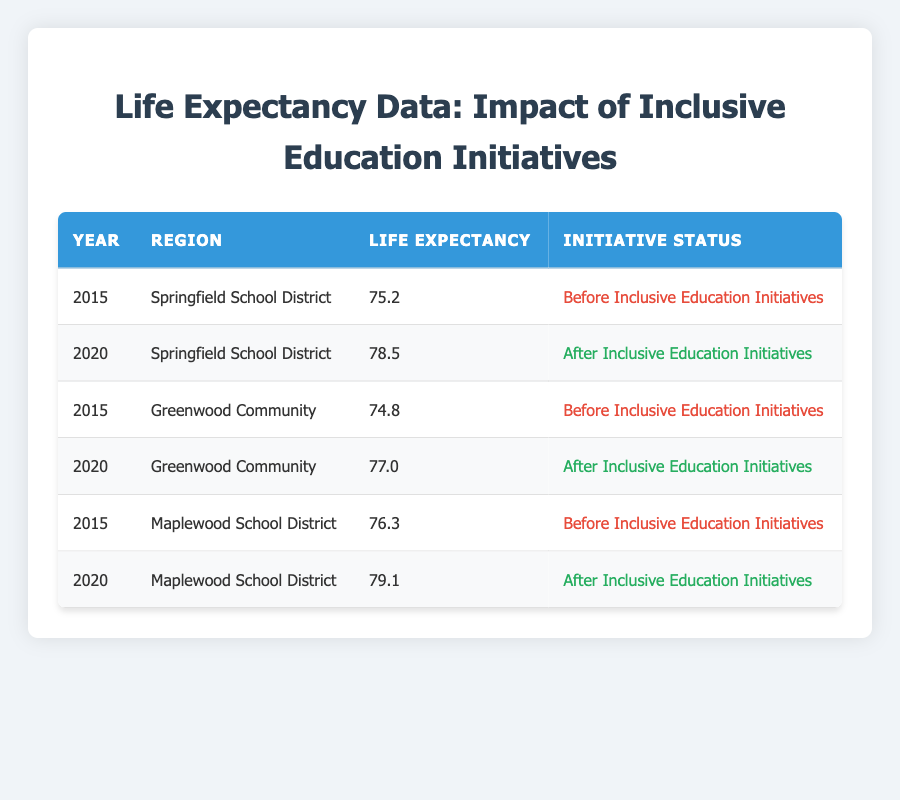What was the life expectancy in Springfield School District before inclusive education initiatives? In the table, we find the row corresponding to the year 2015 for Springfield School District. The life expectancy for that year is listed as 75.2.
Answer: 75.2 What is the life expectancy in Maplewood School District after inclusive education initiatives? Looking at the table, the relevant row for Maplewood School District in the year 2020 shows a life expectancy of 79.1.
Answer: 79.1 Which region had a life expectancy of 74.8 before the inclusive education initiatives? By examining the table, we see that the Greenwood Community shows a life expectancy of 74.8 in the year 2015, which is before the initiatives.
Answer: Greenwood Community What is the increase in life expectancy for Springfield School District from 2015 to 2020? To find this, we take the life expectancy after initiatives (78.5) and subtract the life expectancy before initiatives (75.2): 78.5 - 75.2 = 3.3.
Answer: 3.3 Did life expectancy increase in all regions after the inclusive education initiatives? Analyzing the table, we see that in all regions listed, the life expectancy increased from the years before to after the initiatives: Springfield increased from 75.2 to 78.5, Greenwood from 74.8 to 77.0, and Maplewood from 76.3 to 79.1. Thus, the answer is yes.
Answer: Yes What is the average life expectancy after the inclusive education initiatives across all regions? To find the average after the initiatives, we add the life expectancies after initiatives for all regions: 78.5 (Springfield) + 77.0 (Greenwood) + 79.1 (Maplewood) = 234.6. Then, we divide this sum by the number of regions (3): 234.6 / 3 = 78.2.
Answer: 78.2 Which region had the highest life expectancy after the inclusive education initiatives? The table indicates that Maplewood School District has the highest life expectancy of 79.1, compared to Springfield's 78.5 and Greenwood's 77.0 for the year 2020.
Answer: Maplewood School District What was the life expectancy in Greenwood Community after the inclusive education initiatives? Referring to the table, we look for the year 2020 for Greenwood Community, which shows a life expectancy of 77.0.
Answer: 77.0 Is it true that the life expectancy increased by at least 3 years in Maplewood School District after the initiatives? In the table, the life expectancy for Maplewood School District increased from 76.3 in 2015 to 79.1 in 2020, which is an increase of 2.8 years (79.1 - 76.3 = 2.8). Therefore, the statement is false.
Answer: No 